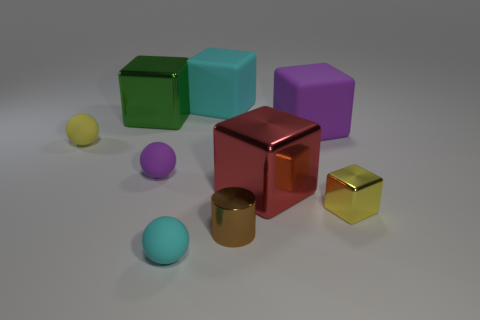Is there anything else that is the same color as the tiny shiny cube?
Your response must be concise. Yes. Do the matte sphere that is to the left of the green thing and the tiny metal cube have the same color?
Your answer should be compact. Yes. How many balls are either yellow things or brown objects?
Your answer should be very brief. 1. What material is the tiny yellow object that is right of the big red shiny thing that is on the right side of the yellow thing that is left of the large purple matte object?
Keep it short and to the point. Metal. There is a sphere that is the same color as the small cube; what is its material?
Provide a succinct answer. Rubber. How many red cubes have the same material as the red thing?
Keep it short and to the point. 0. There is a cyan thing that is behind the green thing; is it the same size as the large green object?
Offer a terse response. Yes. What is the color of the large thing that is made of the same material as the cyan cube?
Ensure brevity in your answer.  Purple. How many large green metallic things are behind the small yellow ball?
Keep it short and to the point. 1. There is a tiny ball that is in front of the tiny yellow metallic object; does it have the same color as the big rubber cube behind the green metal object?
Your response must be concise. Yes. 